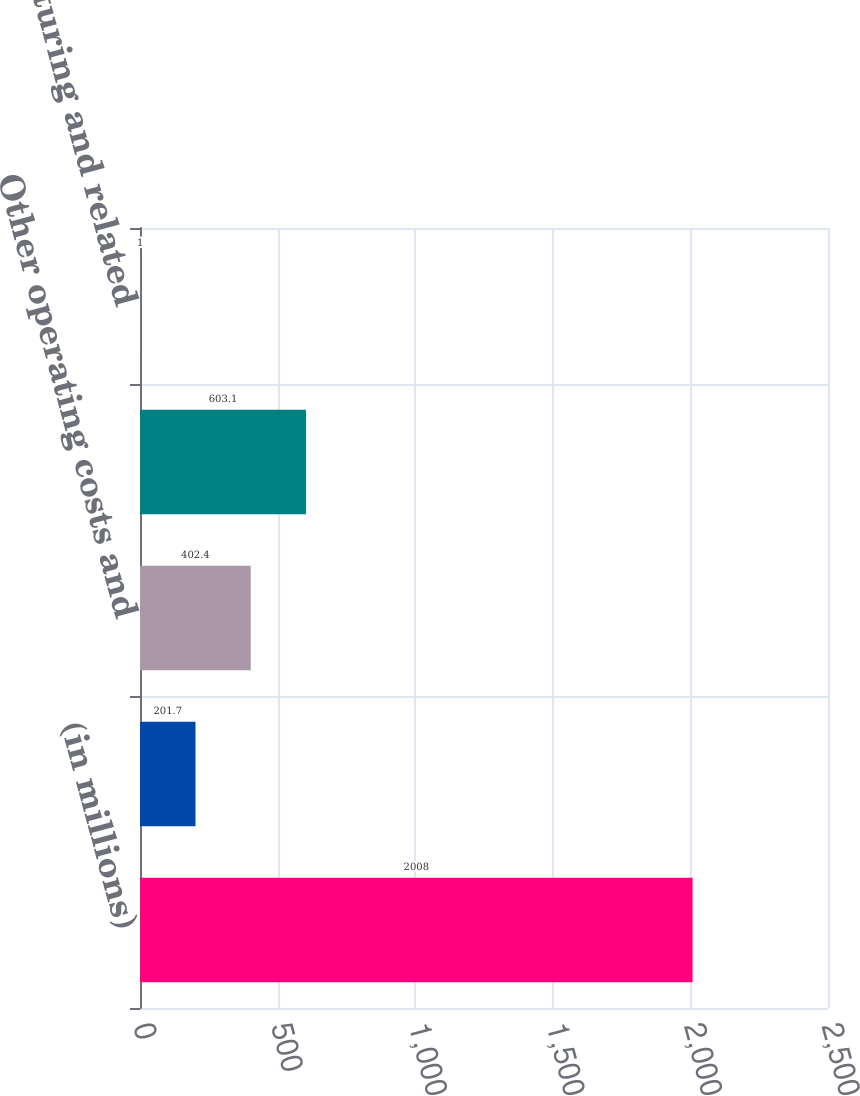<chart> <loc_0><loc_0><loc_500><loc_500><bar_chart><fcel>(in millions)<fcel>Non-deferrable acquisition<fcel>Other operating costs and<fcel>Total operating costs and<fcel>Restructuring and related<nl><fcel>2008<fcel>201.7<fcel>402.4<fcel>603.1<fcel>1<nl></chart> 